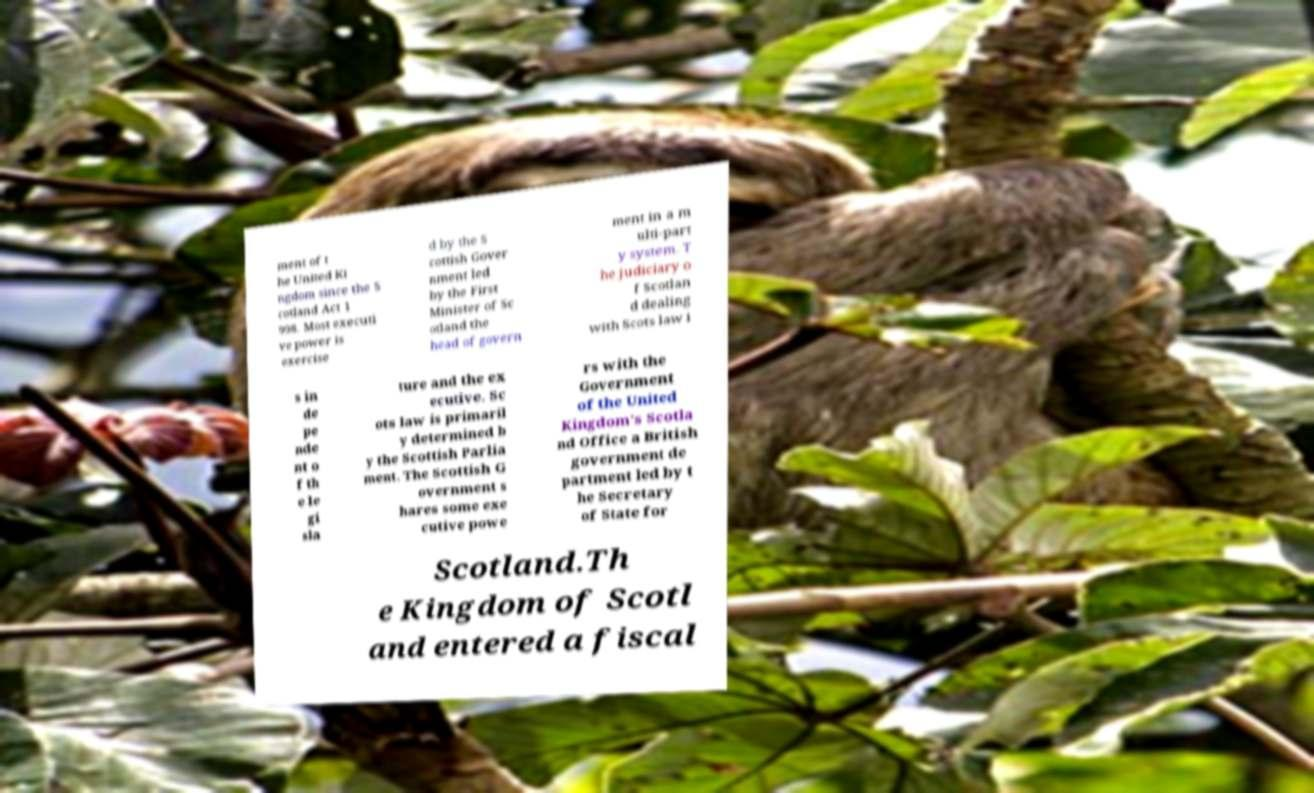Could you extract and type out the text from this image? ment of t he United Ki ngdom since the S cotland Act 1 998. Most executi ve power is exercise d by the S cottish Gover nment led by the First Minister of Sc otland the head of govern ment in a m ulti-part y system. T he judiciary o f Scotlan d dealing with Scots law i s in de pe nde nt o f th e le gi sla ture and the ex ecutive. Sc ots law is primaril y determined b y the Scottish Parlia ment. The Scottish G overnment s hares some exe cutive powe rs with the Government of the United Kingdom's Scotla nd Office a British government de partment led by t he Secretary of State for Scotland.Th e Kingdom of Scotl and entered a fiscal 